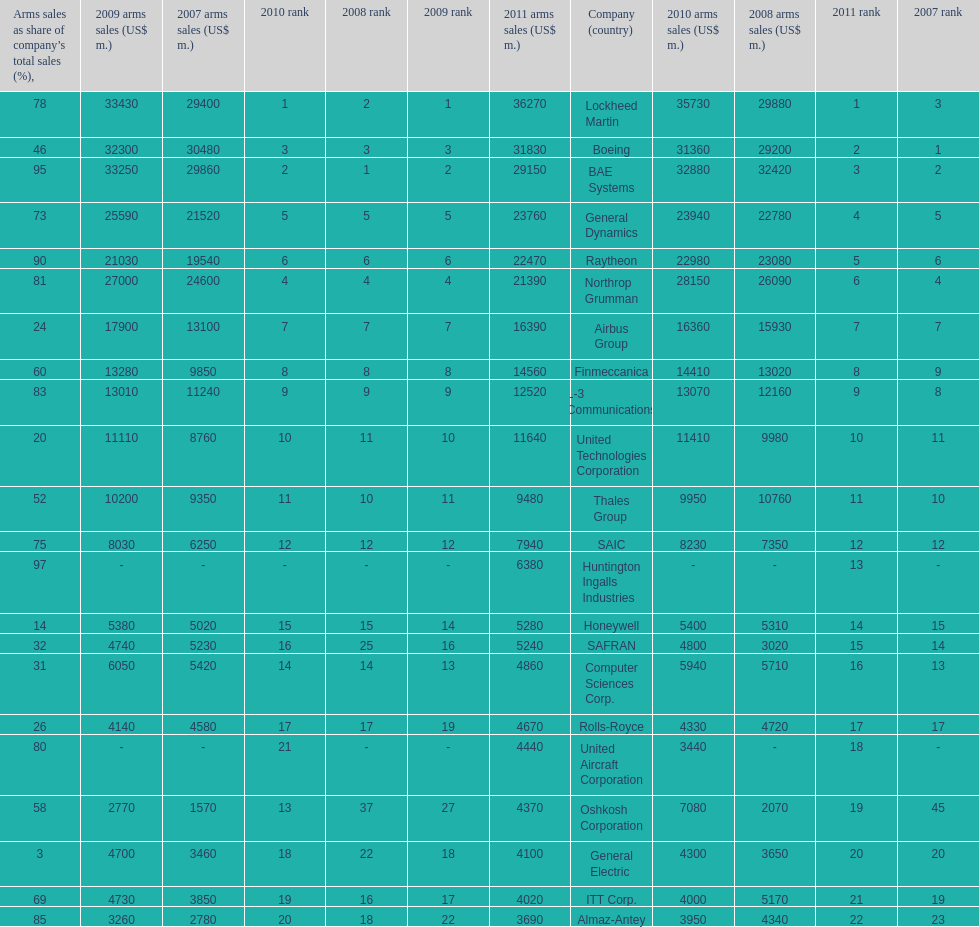Which company had the highest 2009 arms sales? Lockheed Martin. 